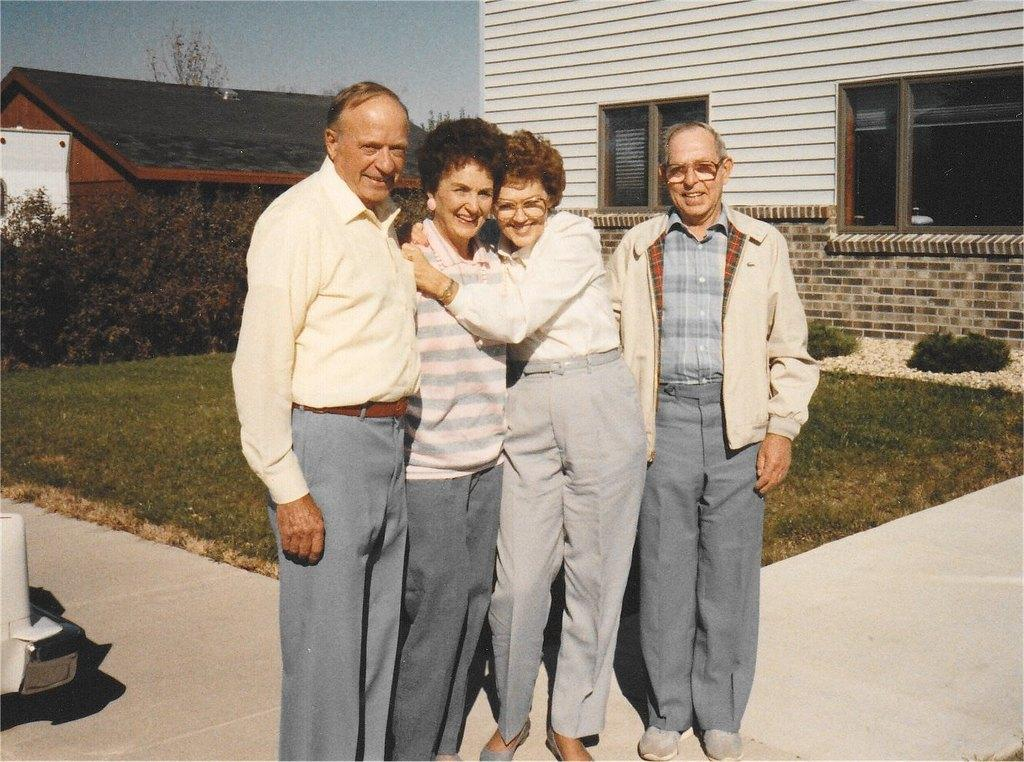How many people are in the image? There is a group of people standing in the image, but the exact number is not specified. What can be seen in the background of the image? There are plants and buildings in the background of the image. How would you describe the sky in the image? The sky is visible in the image, with colors described as white and blue. What type of bird is perched on the selection of plants in the image? There is no bird present in the image, and the plants are not described as a selection. 